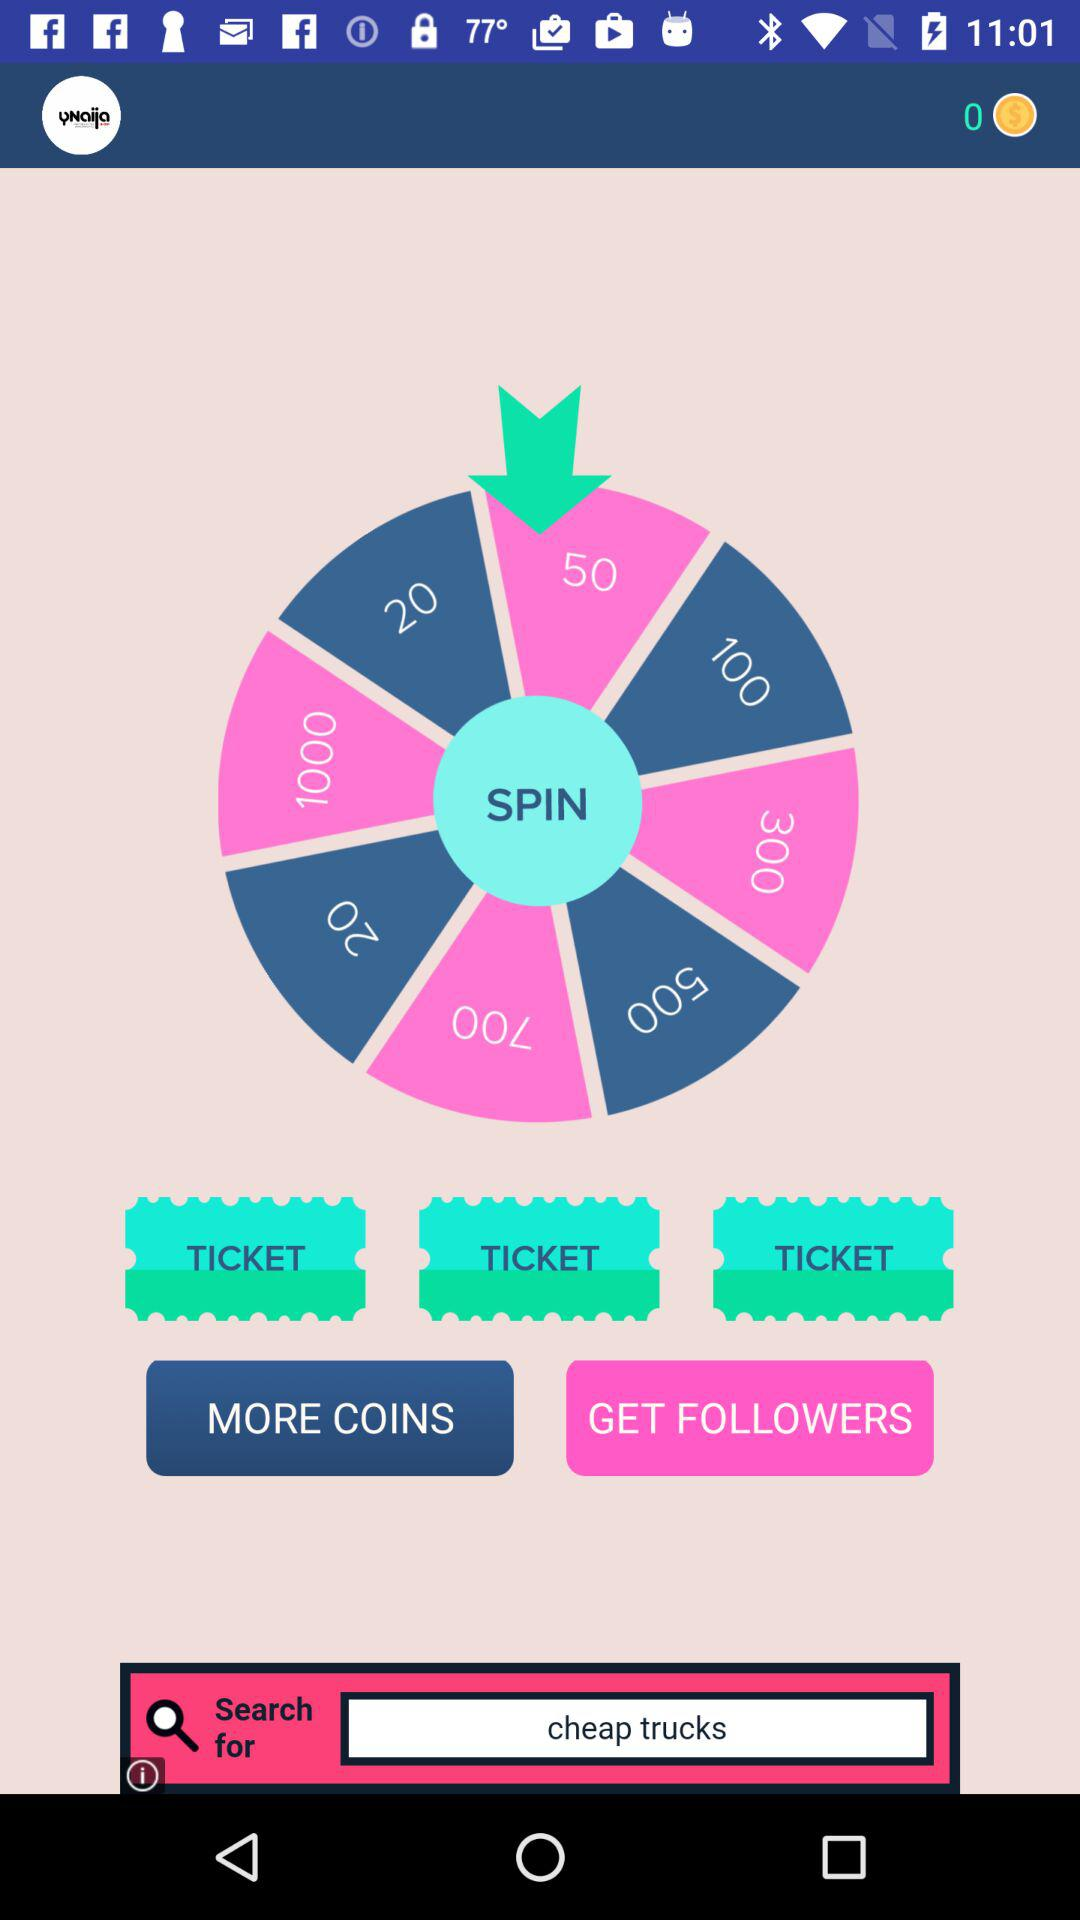What is the number of coins in the balance? The number of coins in the balance is 0. 